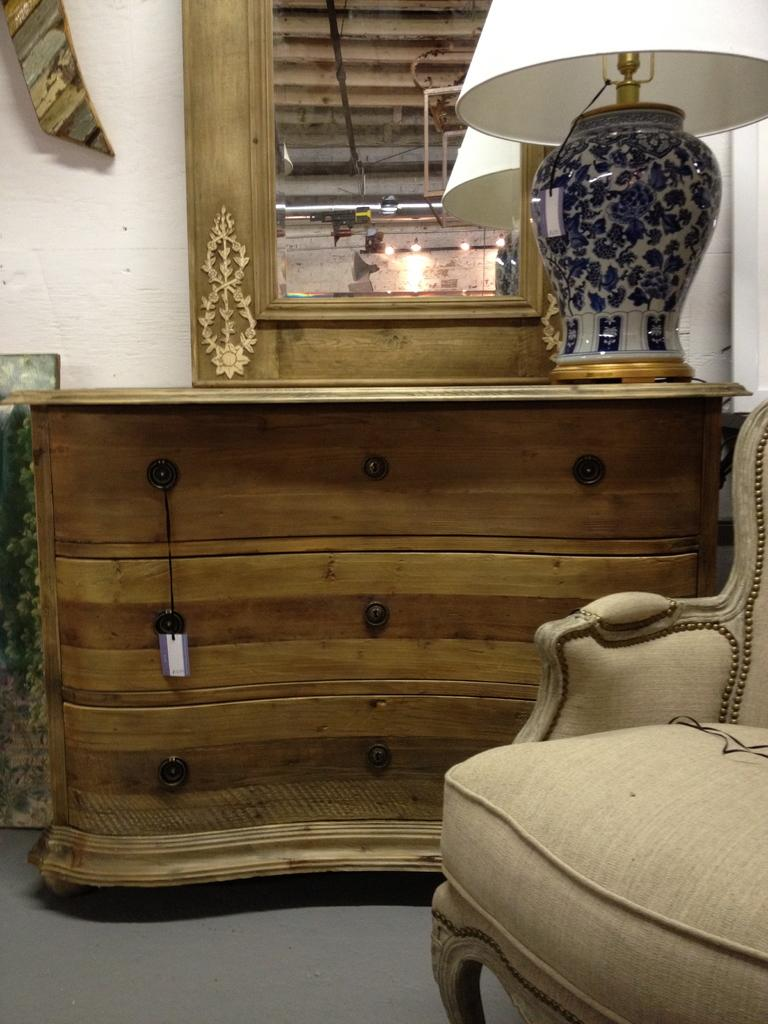What type of furniture is present in the room? There is a dressing table, a desk, a lamp, and a sofa in the room. Can you describe the lighting in the room? There is a lamp in the room, which provides lighting. What type of seating is available in the room? There is a sofa in the room for seating. What type of leather is used to make the twig in the room? There is no twig present in the room, and therefore no leather or material can be associated with it. 